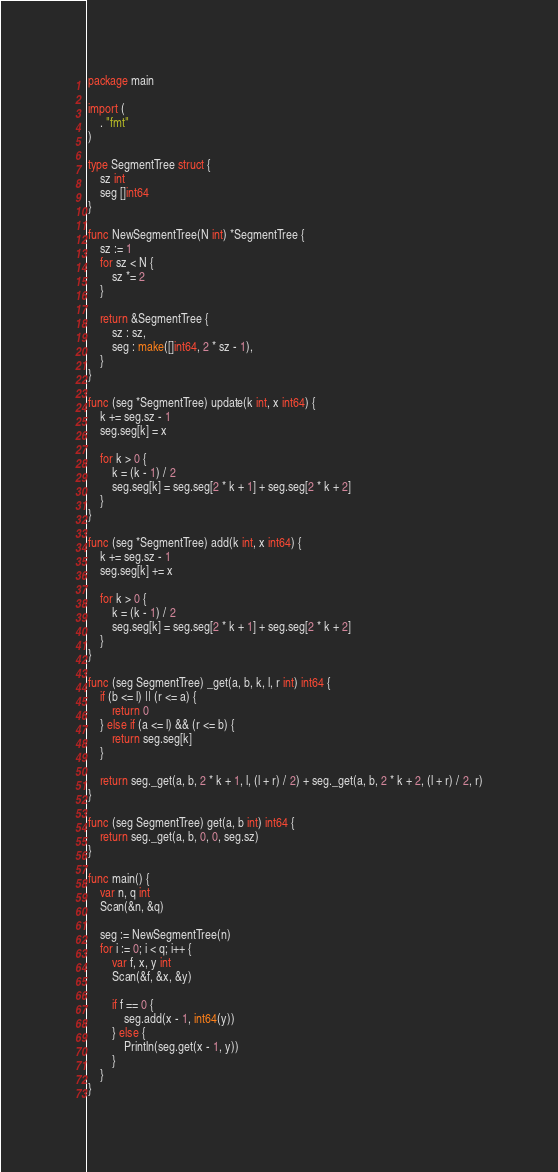<code> <loc_0><loc_0><loc_500><loc_500><_Go_>package main

import (
	. "fmt"
)

type SegmentTree struct {
	sz int
	seg []int64
}

func NewSegmentTree(N int) *SegmentTree {
	sz := 1
	for sz < N {
		sz *= 2
	}

	return &SegmentTree {
		sz : sz,
		seg : make([]int64, 2 * sz - 1),
	}
}

func (seg *SegmentTree) update(k int, x int64) {
	k += seg.sz - 1
	seg.seg[k] = x

	for k > 0 {
		k = (k - 1) / 2
		seg.seg[k] = seg.seg[2 * k + 1] + seg.seg[2 * k + 2]
	}
}

func (seg *SegmentTree) add(k int, x int64) {
	k += seg.sz - 1
	seg.seg[k] += x

	for k > 0 {
		k = (k - 1) / 2
		seg.seg[k] = seg.seg[2 * k + 1] + seg.seg[2 * k + 2]
	}
}

func (seg SegmentTree) _get(a, b, k, l, r int) int64 {
	if (b <= l) || (r <= a) {
		return 0
	} else if (a <= l) && (r <= b) {
		return seg.seg[k]
	}

	return seg._get(a, b, 2 * k + 1, l, (l + r) / 2) + seg._get(a, b, 2 * k + 2, (l + r) / 2, r)
}

func (seg SegmentTree) get(a, b int) int64 {
	return seg._get(a, b, 0, 0, seg.sz)
}

func main() {
	var n, q int
	Scan(&n, &q)
	
	seg := NewSegmentTree(n)
	for i := 0; i < q; i++ {
		var f, x, y int
		Scan(&f, &x, &y)

		if f == 0 {
			seg.add(x - 1, int64(y))
		} else {
			Println(seg.get(x - 1, y))
		}
	}
}
</code> 